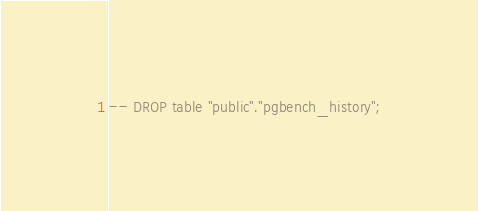Convert code to text. <code><loc_0><loc_0><loc_500><loc_500><_SQL_>-- DROP table "public"."pgbench_history";
</code> 